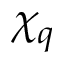Convert formula to latex. <formula><loc_0><loc_0><loc_500><loc_500>\chi _ { q }</formula> 